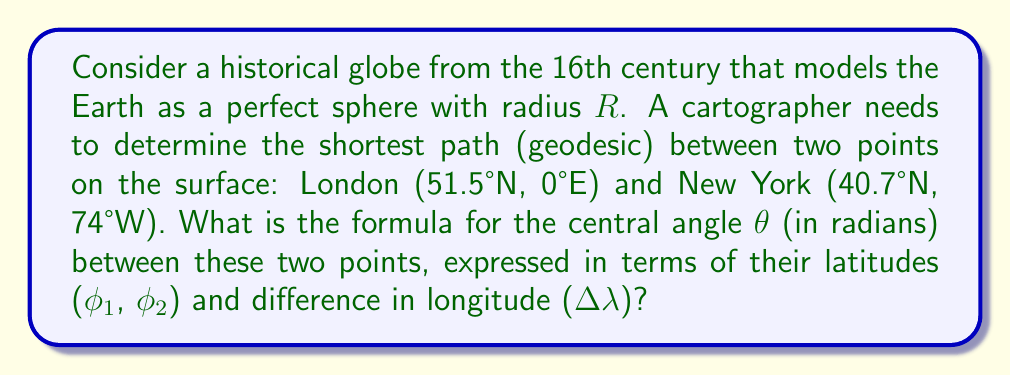Can you answer this question? To find the formula for the central angle $\theta$ between two points on a sphere, we can follow these steps:

1. Recall the spherical law of cosines for a spherical triangle:
   $$\cos(c) = \sin(a)\sin(b) + \cos(a)\cos(b)\cos(C)$$
   where $a$, $b$, and $c$ are the sides of the spherical triangle (measured as central angles), and $C$ is the angle opposite side $c$.

2. In our case:
   - $c$ corresponds to $\theta$, the central angle we're looking for
   - $a$ and $b$ correspond to the co-latitudes of the two points: $(90° - \phi_1)$ and $(90° - \phi_2)$
   - $C$ corresponds to the difference in longitude $\Delta \lambda$

3. Substituting these into the spherical law of cosines:
   $$\cos(\theta) = \sin(90° - \phi_1)\sin(90° - \phi_2) + \cos(90° - \phi_1)\cos(90° - \phi_2)\cos(\Delta \lambda)$$

4. Simplify using trigonometric identities:
   - $\sin(90° - x) = \cos(x)$
   - $\cos(90° - x) = \sin(x)$

5. The formula becomes:
   $$\cos(\theta) = \cos(\phi_1)\cos(\phi_2) + \sin(\phi_1)\sin(\phi_2)\cos(\Delta \lambda)$$

6. To express $\theta$ explicitly, we take the arccos of both sides:
   $$\theta = \arccos(\cos(\phi_1)\cos(\phi_2) + \sin(\phi_1)\sin(\phi_2)\cos(\Delta \lambda))$$

This formula gives the central angle $\theta$ in radians, which when multiplied by the radius $R$ of the sphere, yields the length of the geodesic path between the two points on the surface.
Answer: $\theta = \arccos(\cos(\phi_1)\cos(\phi_2) + \sin(\phi_1)\sin(\phi_2)\cos(\Delta \lambda))$ 